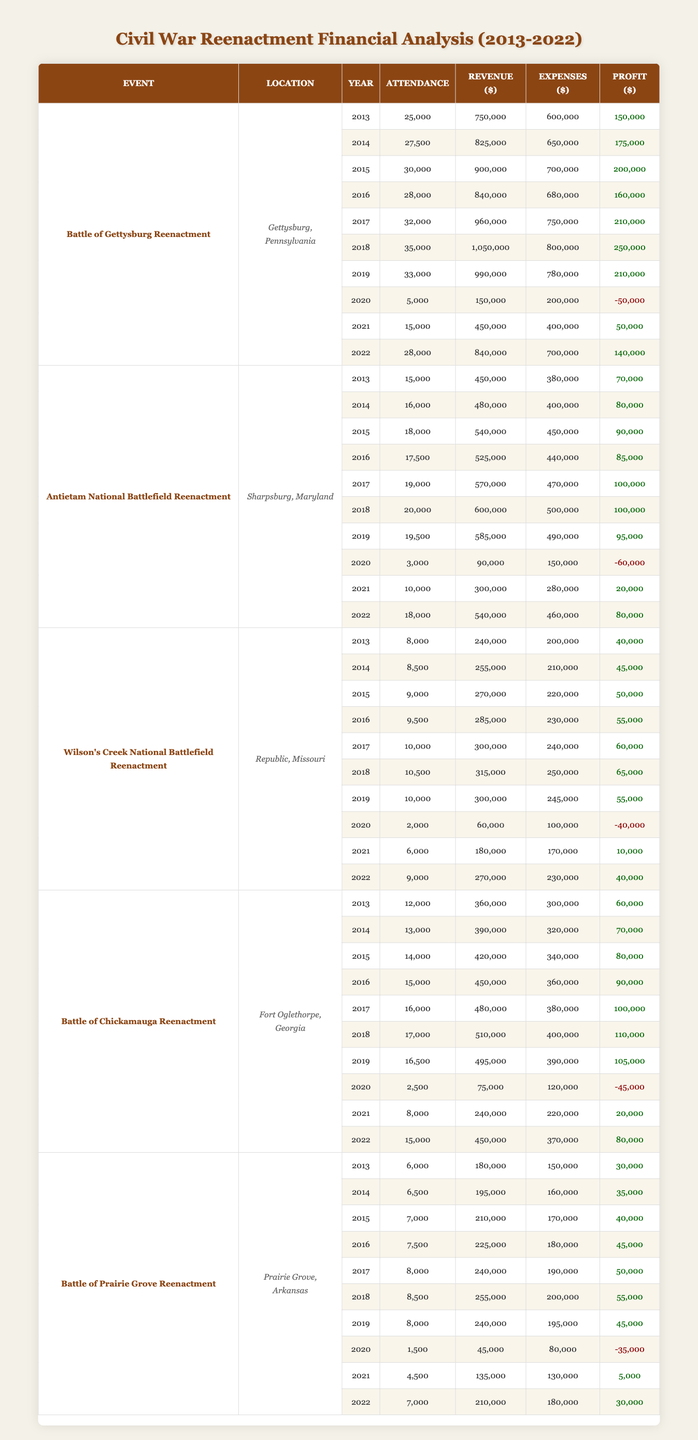What was the highest attendance recorded at the Battle of Gettysburg Reenactment? The highest attendance at the Battle of Gettysburg Reenactment was recorded in 2018, with 35,000 attendees. This can be found by examining the attendance figures listed for each year in the table.
Answer: 35,000 What year had the lowest profit for Antietam National Battlefield Reenactment? The lowest profit for the Antietam National Battlefield Reenactment occurred in 2020, with a profit of -60,000. This is identified by looking through the profit column for each corresponding year to find the minimum value.
Answer: -60,000 Calculate the average revenue for Wilson's Creek National Battlefield Reenactment over the last decade. To calculate the average revenue for Wilson's Creek National Battlefield Reenactment, sum up the revenue figures from each year: 240,000 + 255,000 + 270,000 + 285,000 + 300,000 + 315,000 + 300,000 + 60,000 + 180,000 + 270,000 = 1,885,000. Then divide this total by the number of data points (10 years): 1,885,000 / 10 = 188,500.
Answer: 188,500 Was the profit for the Battle of Chickamauga Reenactment positive in 2020? No, the profit for the Battle of Chickamauga Reenactment in 2020 was -45,000, which indicates a loss. This is determined by checking the profit entry for that particular year in the table.
Answer: No In which year did the Battle of Prairie Grove Reenactment have its highest profit, and what was that amount? The highest profit for the Battle of Prairie Grove Reenactment was in 2018, with a profit of 55,000. This is determined by scanning the profit column for the event and identifying the largest value.
Answer: 55,000 Compare the total profits of the Antietam National Battlefield Reenactment for the years 2013 to 2019 versus 2020 to 2022. Which range had higher total profits? For 2013 to 2019, the profits are: 70,000 + 80,000 + 90,000 + 85,000 + 100,000 + 100,000 + 95,000 = 720,000. For 2020 to 2022, the profits are: -60,000 + 20,000 + 80,000 = 40,000. Therefore, 2013 to 2019 had higher total profits (720,000) compared to 2020 to 2022 (40,000).
Answer: 2013 to 2019 What was the total revenue for the Battle of Gettysburg Reenactment in 2021? The total revenue for the Battle of Gettysburg Reenactment in 2021 was 450,000. This information can be found directly by looking at the revenue column for the year 2021.
Answer: 450,000 How many times did the Battle of Chickamauga Reenactment experience a profit loss in the last decade? The Battle of Chickamauga Reenactment experienced a profit loss two times in the years 2020 and 2021, where the profits were -45,000 and 20,000 respectively. This can be verified by counting the instances in the profit column where the values are negative.
Answer: 2 times Which reenactment event had the highest total attendance over the last decade? The Battle of Gettysburg Reenactment had the highest total attendance over the last decade, totaling 298,500 when all attendance figures from 2013 to 2022 are summed: 25,000 + 27,500 + 30,000 + 28,000 + 32,000 + 35,000 + 33,000 + 5,000 + 15,000 + 28,000.
Answer: Battle of Gettysburg Reenactment 